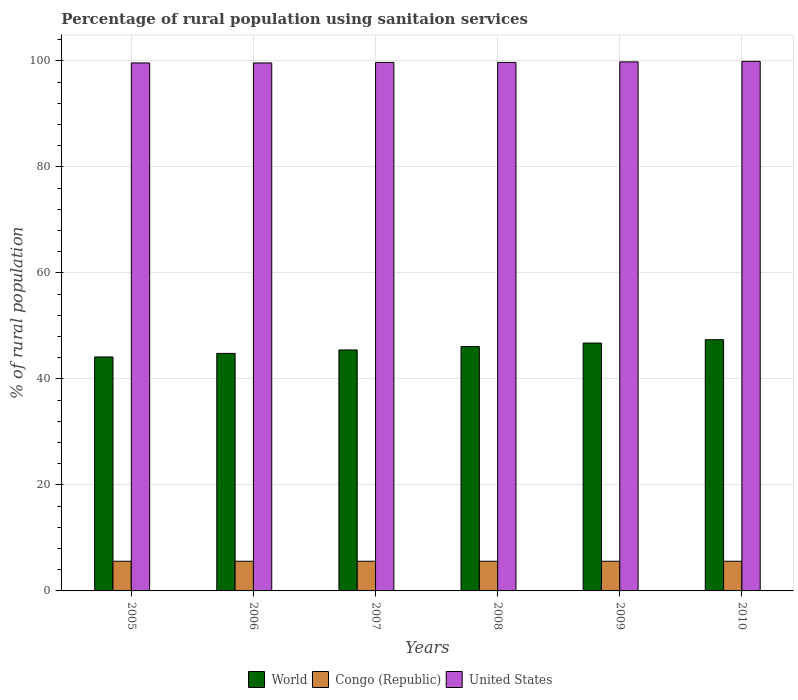How many different coloured bars are there?
Offer a terse response. 3. Are the number of bars per tick equal to the number of legend labels?
Your answer should be very brief. Yes. How many bars are there on the 5th tick from the right?
Ensure brevity in your answer.  3. In how many cases, is the number of bars for a given year not equal to the number of legend labels?
Offer a very short reply. 0. What is the percentage of rural population using sanitaion services in Congo (Republic) in 2010?
Offer a terse response. 5.6. Across all years, what is the maximum percentage of rural population using sanitaion services in Congo (Republic)?
Your response must be concise. 5.6. Across all years, what is the minimum percentage of rural population using sanitaion services in World?
Ensure brevity in your answer.  44.14. What is the total percentage of rural population using sanitaion services in Congo (Republic) in the graph?
Provide a succinct answer. 33.6. What is the difference between the percentage of rural population using sanitaion services in United States in 2008 and that in 2010?
Your response must be concise. -0.2. What is the difference between the percentage of rural population using sanitaion services in World in 2008 and the percentage of rural population using sanitaion services in United States in 2009?
Keep it short and to the point. -53.7. What is the average percentage of rural population using sanitaion services in United States per year?
Offer a terse response. 99.72. In the year 2005, what is the difference between the percentage of rural population using sanitaion services in World and percentage of rural population using sanitaion services in United States?
Offer a very short reply. -55.46. In how many years, is the percentage of rural population using sanitaion services in World greater than 48 %?
Offer a very short reply. 0. What is the ratio of the percentage of rural population using sanitaion services in World in 2008 to that in 2010?
Give a very brief answer. 0.97. Is the percentage of rural population using sanitaion services in United States in 2005 less than that in 2008?
Your answer should be very brief. Yes. Is the difference between the percentage of rural population using sanitaion services in World in 2006 and 2007 greater than the difference between the percentage of rural population using sanitaion services in United States in 2006 and 2007?
Keep it short and to the point. No. What is the difference between the highest and the second highest percentage of rural population using sanitaion services in World?
Offer a very short reply. 0.63. What is the difference between the highest and the lowest percentage of rural population using sanitaion services in United States?
Make the answer very short. 0.3. In how many years, is the percentage of rural population using sanitaion services in Congo (Republic) greater than the average percentage of rural population using sanitaion services in Congo (Republic) taken over all years?
Keep it short and to the point. 0. What does the 3rd bar from the right in 2005 represents?
Your response must be concise. World. Are all the bars in the graph horizontal?
Your answer should be compact. No. What is the difference between two consecutive major ticks on the Y-axis?
Keep it short and to the point. 20. Does the graph contain any zero values?
Give a very brief answer. No. Does the graph contain grids?
Ensure brevity in your answer.  Yes. Where does the legend appear in the graph?
Give a very brief answer. Bottom center. How many legend labels are there?
Ensure brevity in your answer.  3. What is the title of the graph?
Offer a terse response. Percentage of rural population using sanitaion services. What is the label or title of the Y-axis?
Provide a succinct answer. % of rural population. What is the % of rural population in World in 2005?
Provide a short and direct response. 44.14. What is the % of rural population in Congo (Republic) in 2005?
Your response must be concise. 5.6. What is the % of rural population in United States in 2005?
Make the answer very short. 99.6. What is the % of rural population in World in 2006?
Your response must be concise. 44.81. What is the % of rural population in Congo (Republic) in 2006?
Your response must be concise. 5.6. What is the % of rural population in United States in 2006?
Give a very brief answer. 99.6. What is the % of rural population of World in 2007?
Make the answer very short. 45.46. What is the % of rural population in Congo (Republic) in 2007?
Your answer should be compact. 5.6. What is the % of rural population in United States in 2007?
Provide a short and direct response. 99.7. What is the % of rural population in World in 2008?
Your answer should be compact. 46.1. What is the % of rural population in United States in 2008?
Ensure brevity in your answer.  99.7. What is the % of rural population in World in 2009?
Ensure brevity in your answer.  46.76. What is the % of rural population in Congo (Republic) in 2009?
Ensure brevity in your answer.  5.6. What is the % of rural population in United States in 2009?
Your answer should be compact. 99.8. What is the % of rural population in World in 2010?
Ensure brevity in your answer.  47.39. What is the % of rural population in Congo (Republic) in 2010?
Your answer should be compact. 5.6. What is the % of rural population in United States in 2010?
Your answer should be very brief. 99.9. Across all years, what is the maximum % of rural population of World?
Offer a terse response. 47.39. Across all years, what is the maximum % of rural population of United States?
Provide a succinct answer. 99.9. Across all years, what is the minimum % of rural population in World?
Ensure brevity in your answer.  44.14. Across all years, what is the minimum % of rural population of Congo (Republic)?
Your answer should be compact. 5.6. Across all years, what is the minimum % of rural population in United States?
Your response must be concise. 99.6. What is the total % of rural population in World in the graph?
Your answer should be compact. 274.65. What is the total % of rural population in Congo (Republic) in the graph?
Ensure brevity in your answer.  33.6. What is the total % of rural population of United States in the graph?
Provide a succinct answer. 598.3. What is the difference between the % of rural population of World in 2005 and that in 2006?
Make the answer very short. -0.67. What is the difference between the % of rural population in United States in 2005 and that in 2006?
Your response must be concise. 0. What is the difference between the % of rural population in World in 2005 and that in 2007?
Give a very brief answer. -1.32. What is the difference between the % of rural population in Congo (Republic) in 2005 and that in 2007?
Your response must be concise. 0. What is the difference between the % of rural population of United States in 2005 and that in 2007?
Make the answer very short. -0.1. What is the difference between the % of rural population of World in 2005 and that in 2008?
Your answer should be compact. -1.97. What is the difference between the % of rural population of Congo (Republic) in 2005 and that in 2008?
Offer a very short reply. 0. What is the difference between the % of rural population of World in 2005 and that in 2009?
Your response must be concise. -2.62. What is the difference between the % of rural population in Congo (Republic) in 2005 and that in 2009?
Offer a terse response. 0. What is the difference between the % of rural population of United States in 2005 and that in 2009?
Make the answer very short. -0.2. What is the difference between the % of rural population in World in 2005 and that in 2010?
Keep it short and to the point. -3.25. What is the difference between the % of rural population in Congo (Republic) in 2005 and that in 2010?
Provide a short and direct response. 0. What is the difference between the % of rural population in United States in 2005 and that in 2010?
Make the answer very short. -0.3. What is the difference between the % of rural population of World in 2006 and that in 2007?
Provide a short and direct response. -0.65. What is the difference between the % of rural population in Congo (Republic) in 2006 and that in 2007?
Your answer should be very brief. 0. What is the difference between the % of rural population in United States in 2006 and that in 2007?
Ensure brevity in your answer.  -0.1. What is the difference between the % of rural population of World in 2006 and that in 2008?
Keep it short and to the point. -1.29. What is the difference between the % of rural population of Congo (Republic) in 2006 and that in 2008?
Offer a terse response. 0. What is the difference between the % of rural population in United States in 2006 and that in 2008?
Your answer should be very brief. -0.1. What is the difference between the % of rural population of World in 2006 and that in 2009?
Give a very brief answer. -1.95. What is the difference between the % of rural population in Congo (Republic) in 2006 and that in 2009?
Provide a succinct answer. 0. What is the difference between the % of rural population in United States in 2006 and that in 2009?
Keep it short and to the point. -0.2. What is the difference between the % of rural population of World in 2006 and that in 2010?
Your response must be concise. -2.58. What is the difference between the % of rural population of United States in 2006 and that in 2010?
Your answer should be compact. -0.3. What is the difference between the % of rural population in World in 2007 and that in 2008?
Your answer should be very brief. -0.64. What is the difference between the % of rural population in Congo (Republic) in 2007 and that in 2008?
Provide a succinct answer. 0. What is the difference between the % of rural population of World in 2007 and that in 2009?
Ensure brevity in your answer.  -1.3. What is the difference between the % of rural population of United States in 2007 and that in 2009?
Ensure brevity in your answer.  -0.1. What is the difference between the % of rural population of World in 2007 and that in 2010?
Make the answer very short. -1.93. What is the difference between the % of rural population of United States in 2007 and that in 2010?
Offer a very short reply. -0.2. What is the difference between the % of rural population of World in 2008 and that in 2009?
Keep it short and to the point. -0.66. What is the difference between the % of rural population in United States in 2008 and that in 2009?
Keep it short and to the point. -0.1. What is the difference between the % of rural population in World in 2008 and that in 2010?
Offer a very short reply. -1.29. What is the difference between the % of rural population in United States in 2008 and that in 2010?
Provide a short and direct response. -0.2. What is the difference between the % of rural population in World in 2009 and that in 2010?
Provide a short and direct response. -0.63. What is the difference between the % of rural population in World in 2005 and the % of rural population in Congo (Republic) in 2006?
Keep it short and to the point. 38.54. What is the difference between the % of rural population of World in 2005 and the % of rural population of United States in 2006?
Make the answer very short. -55.46. What is the difference between the % of rural population in Congo (Republic) in 2005 and the % of rural population in United States in 2006?
Your answer should be very brief. -94. What is the difference between the % of rural population in World in 2005 and the % of rural population in Congo (Republic) in 2007?
Ensure brevity in your answer.  38.54. What is the difference between the % of rural population in World in 2005 and the % of rural population in United States in 2007?
Give a very brief answer. -55.56. What is the difference between the % of rural population of Congo (Republic) in 2005 and the % of rural population of United States in 2007?
Offer a terse response. -94.1. What is the difference between the % of rural population in World in 2005 and the % of rural population in Congo (Republic) in 2008?
Provide a short and direct response. 38.54. What is the difference between the % of rural population in World in 2005 and the % of rural population in United States in 2008?
Your answer should be very brief. -55.56. What is the difference between the % of rural population in Congo (Republic) in 2005 and the % of rural population in United States in 2008?
Your answer should be compact. -94.1. What is the difference between the % of rural population in World in 2005 and the % of rural population in Congo (Republic) in 2009?
Offer a terse response. 38.54. What is the difference between the % of rural population in World in 2005 and the % of rural population in United States in 2009?
Provide a succinct answer. -55.66. What is the difference between the % of rural population of Congo (Republic) in 2005 and the % of rural population of United States in 2009?
Your response must be concise. -94.2. What is the difference between the % of rural population in World in 2005 and the % of rural population in Congo (Republic) in 2010?
Offer a terse response. 38.54. What is the difference between the % of rural population of World in 2005 and the % of rural population of United States in 2010?
Offer a very short reply. -55.76. What is the difference between the % of rural population in Congo (Republic) in 2005 and the % of rural population in United States in 2010?
Offer a terse response. -94.3. What is the difference between the % of rural population of World in 2006 and the % of rural population of Congo (Republic) in 2007?
Provide a short and direct response. 39.21. What is the difference between the % of rural population in World in 2006 and the % of rural population in United States in 2007?
Your response must be concise. -54.89. What is the difference between the % of rural population in Congo (Republic) in 2006 and the % of rural population in United States in 2007?
Offer a terse response. -94.1. What is the difference between the % of rural population of World in 2006 and the % of rural population of Congo (Republic) in 2008?
Give a very brief answer. 39.21. What is the difference between the % of rural population in World in 2006 and the % of rural population in United States in 2008?
Keep it short and to the point. -54.89. What is the difference between the % of rural population in Congo (Republic) in 2006 and the % of rural population in United States in 2008?
Keep it short and to the point. -94.1. What is the difference between the % of rural population of World in 2006 and the % of rural population of Congo (Republic) in 2009?
Keep it short and to the point. 39.21. What is the difference between the % of rural population in World in 2006 and the % of rural population in United States in 2009?
Your answer should be very brief. -54.99. What is the difference between the % of rural population of Congo (Republic) in 2006 and the % of rural population of United States in 2009?
Keep it short and to the point. -94.2. What is the difference between the % of rural population of World in 2006 and the % of rural population of Congo (Republic) in 2010?
Your answer should be very brief. 39.21. What is the difference between the % of rural population in World in 2006 and the % of rural population in United States in 2010?
Make the answer very short. -55.09. What is the difference between the % of rural population of Congo (Republic) in 2006 and the % of rural population of United States in 2010?
Offer a very short reply. -94.3. What is the difference between the % of rural population in World in 2007 and the % of rural population in Congo (Republic) in 2008?
Your answer should be very brief. 39.86. What is the difference between the % of rural population in World in 2007 and the % of rural population in United States in 2008?
Give a very brief answer. -54.24. What is the difference between the % of rural population in Congo (Republic) in 2007 and the % of rural population in United States in 2008?
Your response must be concise. -94.1. What is the difference between the % of rural population of World in 2007 and the % of rural population of Congo (Republic) in 2009?
Provide a succinct answer. 39.86. What is the difference between the % of rural population of World in 2007 and the % of rural population of United States in 2009?
Your answer should be compact. -54.34. What is the difference between the % of rural population in Congo (Republic) in 2007 and the % of rural population in United States in 2009?
Ensure brevity in your answer.  -94.2. What is the difference between the % of rural population of World in 2007 and the % of rural population of Congo (Republic) in 2010?
Your answer should be very brief. 39.86. What is the difference between the % of rural population of World in 2007 and the % of rural population of United States in 2010?
Provide a succinct answer. -54.44. What is the difference between the % of rural population in Congo (Republic) in 2007 and the % of rural population in United States in 2010?
Provide a succinct answer. -94.3. What is the difference between the % of rural population in World in 2008 and the % of rural population in Congo (Republic) in 2009?
Provide a succinct answer. 40.5. What is the difference between the % of rural population in World in 2008 and the % of rural population in United States in 2009?
Make the answer very short. -53.7. What is the difference between the % of rural population in Congo (Republic) in 2008 and the % of rural population in United States in 2009?
Offer a terse response. -94.2. What is the difference between the % of rural population in World in 2008 and the % of rural population in Congo (Republic) in 2010?
Make the answer very short. 40.5. What is the difference between the % of rural population of World in 2008 and the % of rural population of United States in 2010?
Make the answer very short. -53.8. What is the difference between the % of rural population of Congo (Republic) in 2008 and the % of rural population of United States in 2010?
Provide a succinct answer. -94.3. What is the difference between the % of rural population of World in 2009 and the % of rural population of Congo (Republic) in 2010?
Keep it short and to the point. 41.16. What is the difference between the % of rural population of World in 2009 and the % of rural population of United States in 2010?
Make the answer very short. -53.14. What is the difference between the % of rural population of Congo (Republic) in 2009 and the % of rural population of United States in 2010?
Give a very brief answer. -94.3. What is the average % of rural population of World per year?
Make the answer very short. 45.77. What is the average % of rural population in United States per year?
Make the answer very short. 99.72. In the year 2005, what is the difference between the % of rural population of World and % of rural population of Congo (Republic)?
Make the answer very short. 38.54. In the year 2005, what is the difference between the % of rural population in World and % of rural population in United States?
Make the answer very short. -55.46. In the year 2005, what is the difference between the % of rural population in Congo (Republic) and % of rural population in United States?
Give a very brief answer. -94. In the year 2006, what is the difference between the % of rural population of World and % of rural population of Congo (Republic)?
Your response must be concise. 39.21. In the year 2006, what is the difference between the % of rural population in World and % of rural population in United States?
Ensure brevity in your answer.  -54.79. In the year 2006, what is the difference between the % of rural population in Congo (Republic) and % of rural population in United States?
Your answer should be very brief. -94. In the year 2007, what is the difference between the % of rural population in World and % of rural population in Congo (Republic)?
Give a very brief answer. 39.86. In the year 2007, what is the difference between the % of rural population of World and % of rural population of United States?
Your answer should be compact. -54.24. In the year 2007, what is the difference between the % of rural population of Congo (Republic) and % of rural population of United States?
Offer a very short reply. -94.1. In the year 2008, what is the difference between the % of rural population in World and % of rural population in Congo (Republic)?
Offer a terse response. 40.5. In the year 2008, what is the difference between the % of rural population of World and % of rural population of United States?
Your answer should be very brief. -53.6. In the year 2008, what is the difference between the % of rural population of Congo (Republic) and % of rural population of United States?
Keep it short and to the point. -94.1. In the year 2009, what is the difference between the % of rural population in World and % of rural population in Congo (Republic)?
Provide a succinct answer. 41.16. In the year 2009, what is the difference between the % of rural population in World and % of rural population in United States?
Provide a short and direct response. -53.04. In the year 2009, what is the difference between the % of rural population in Congo (Republic) and % of rural population in United States?
Keep it short and to the point. -94.2. In the year 2010, what is the difference between the % of rural population in World and % of rural population in Congo (Republic)?
Provide a succinct answer. 41.79. In the year 2010, what is the difference between the % of rural population in World and % of rural population in United States?
Offer a terse response. -52.51. In the year 2010, what is the difference between the % of rural population of Congo (Republic) and % of rural population of United States?
Ensure brevity in your answer.  -94.3. What is the ratio of the % of rural population of World in 2005 to that in 2006?
Provide a succinct answer. 0.98. What is the ratio of the % of rural population of Congo (Republic) in 2005 to that in 2006?
Your response must be concise. 1. What is the ratio of the % of rural population of World in 2005 to that in 2007?
Offer a terse response. 0.97. What is the ratio of the % of rural population of United States in 2005 to that in 2007?
Your answer should be compact. 1. What is the ratio of the % of rural population in World in 2005 to that in 2008?
Give a very brief answer. 0.96. What is the ratio of the % of rural population of Congo (Republic) in 2005 to that in 2008?
Offer a terse response. 1. What is the ratio of the % of rural population in World in 2005 to that in 2009?
Offer a terse response. 0.94. What is the ratio of the % of rural population of World in 2005 to that in 2010?
Offer a very short reply. 0.93. What is the ratio of the % of rural population in Congo (Republic) in 2005 to that in 2010?
Your response must be concise. 1. What is the ratio of the % of rural population of United States in 2005 to that in 2010?
Keep it short and to the point. 1. What is the ratio of the % of rural population in World in 2006 to that in 2007?
Keep it short and to the point. 0.99. What is the ratio of the % of rural population in Congo (Republic) in 2006 to that in 2007?
Your answer should be compact. 1. What is the ratio of the % of rural population in World in 2006 to that in 2008?
Offer a terse response. 0.97. What is the ratio of the % of rural population in World in 2006 to that in 2009?
Ensure brevity in your answer.  0.96. What is the ratio of the % of rural population of World in 2006 to that in 2010?
Provide a short and direct response. 0.95. What is the ratio of the % of rural population in Congo (Republic) in 2006 to that in 2010?
Offer a terse response. 1. What is the ratio of the % of rural population of United States in 2006 to that in 2010?
Offer a very short reply. 1. What is the ratio of the % of rural population of Congo (Republic) in 2007 to that in 2008?
Give a very brief answer. 1. What is the ratio of the % of rural population of United States in 2007 to that in 2008?
Make the answer very short. 1. What is the ratio of the % of rural population in World in 2007 to that in 2009?
Provide a succinct answer. 0.97. What is the ratio of the % of rural population of United States in 2007 to that in 2009?
Offer a very short reply. 1. What is the ratio of the % of rural population of World in 2007 to that in 2010?
Offer a very short reply. 0.96. What is the ratio of the % of rural population in United States in 2007 to that in 2010?
Offer a very short reply. 1. What is the ratio of the % of rural population of World in 2008 to that in 2009?
Offer a terse response. 0.99. What is the ratio of the % of rural population in World in 2008 to that in 2010?
Make the answer very short. 0.97. What is the ratio of the % of rural population of Congo (Republic) in 2008 to that in 2010?
Offer a terse response. 1. What is the ratio of the % of rural population of World in 2009 to that in 2010?
Make the answer very short. 0.99. What is the difference between the highest and the second highest % of rural population of World?
Give a very brief answer. 0.63. What is the difference between the highest and the lowest % of rural population in World?
Your answer should be compact. 3.25. What is the difference between the highest and the lowest % of rural population of Congo (Republic)?
Provide a succinct answer. 0. 